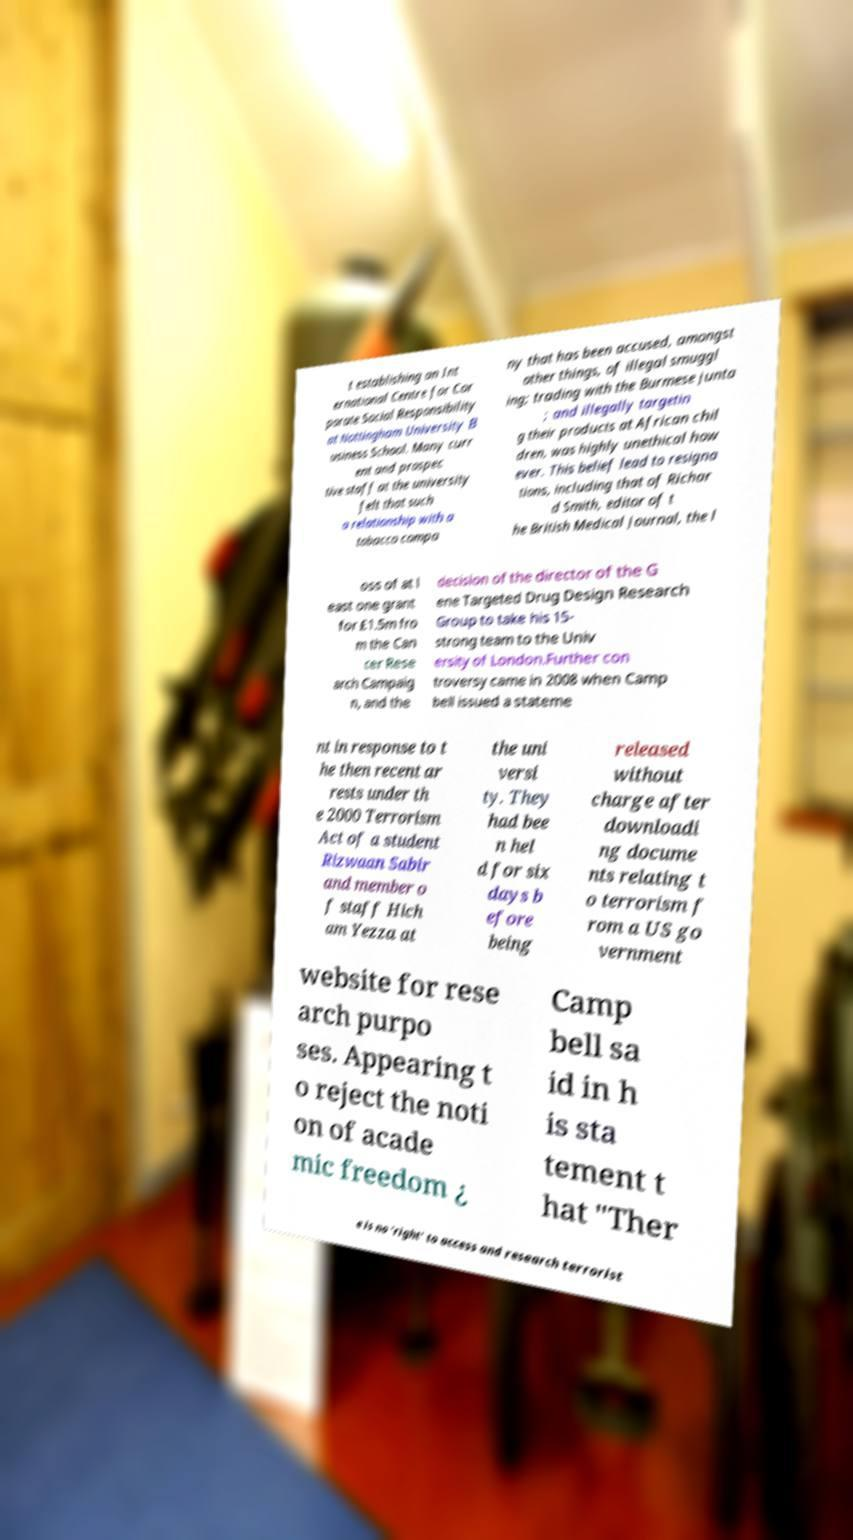Could you assist in decoding the text presented in this image and type it out clearly? t establishing an Int ernational Centre for Cor porate Social Responsibility at Nottingham University B usiness School. Many curr ent and prospec tive staff at the university felt that such a relationship with a tobacco compa ny that has been accused, amongst other things, of illegal smuggl ing; trading with the Burmese junta ; and illegally targetin g their products at African chil dren, was highly unethical how ever. This belief lead to resigna tions, including that of Richar d Smith, editor of t he British Medical Journal, the l oss of at l east one grant for £1.5m fro m the Can cer Rese arch Campaig n, and the decision of the director of the G ene Targeted Drug Design Research Group to take his 15- strong team to the Univ ersity of London.Further con troversy came in 2008 when Camp bell issued a stateme nt in response to t he then recent ar rests under th e 2000 Terrorism Act of a student Rizwaan Sabir and member o f staff Hich am Yezza at the uni versi ty. They had bee n hel d for six days b efore being released without charge after downloadi ng docume nts relating t o terrorism f rom a US go vernment website for rese arch purpo ses. Appearing t o reject the noti on of acade mic freedom ¿ Camp bell sa id in h is sta tement t hat "Ther e is no 'right' to access and research terrorist 